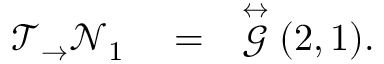Convert formula to latex. <formula><loc_0><loc_0><loc_500><loc_500>\begin{array} { r l r } { \mathcal { T } _ { \rightarrow } \mathcal { N } _ { 1 } } & = } & { \stackrel { \leftrightarrow } { \mathcal { G } } ( 2 , 1 ) . } \end{array}</formula> 